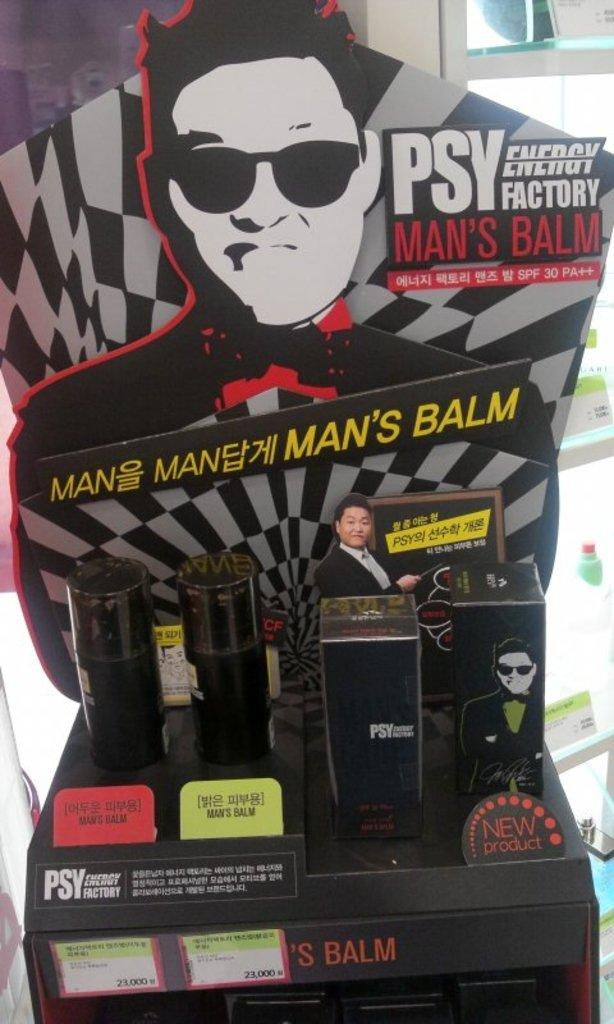<image>
Create a compact narrative representing the image presented. a display with mens balm is sitting on the floor 